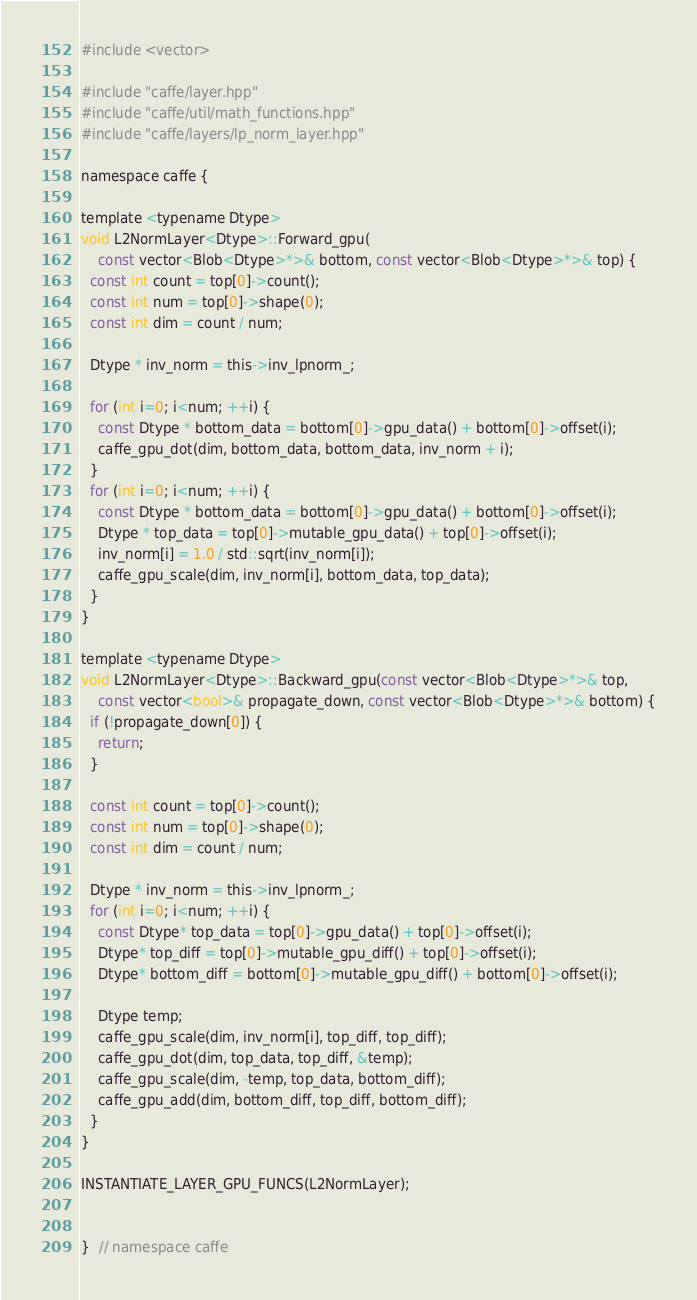<code> <loc_0><loc_0><loc_500><loc_500><_Cuda_>#include <vector>

#include "caffe/layer.hpp"
#include "caffe/util/math_functions.hpp"
#include "caffe/layers/lp_norm_layer.hpp"

namespace caffe {

template <typename Dtype>
void L2NormLayer<Dtype>::Forward_gpu(
    const vector<Blob<Dtype>*>& bottom, const vector<Blob<Dtype>*>& top) {
  const int count = top[0]->count();
  const int num = top[0]->shape(0);
  const int dim = count / num;

  Dtype * inv_norm = this->inv_lpnorm_;

  for (int i=0; i<num; ++i) {
    const Dtype * bottom_data = bottom[0]->gpu_data() + bottom[0]->offset(i);
    caffe_gpu_dot(dim, bottom_data, bottom_data, inv_norm + i);
  }
  for (int i=0; i<num; ++i) {
    const Dtype * bottom_data = bottom[0]->gpu_data() + bottom[0]->offset(i);
    Dtype * top_data = top[0]->mutable_gpu_data() + top[0]->offset(i);
    inv_norm[i] = 1.0 / std::sqrt(inv_norm[i]);
    caffe_gpu_scale(dim, inv_norm[i], bottom_data, top_data);
  }
}

template <typename Dtype>
void L2NormLayer<Dtype>::Backward_gpu(const vector<Blob<Dtype>*>& top,
    const vector<bool>& propagate_down, const vector<Blob<Dtype>*>& bottom) {
  if (!propagate_down[0]) {
    return;
  }

  const int count = top[0]->count();
  const int num = top[0]->shape(0);
  const int dim = count / num;

  Dtype * inv_norm = this->inv_lpnorm_;
  for (int i=0; i<num; ++i) {
    const Dtype* top_data = top[0]->gpu_data() + top[0]->offset(i);
    Dtype* top_diff = top[0]->mutable_gpu_diff() + top[0]->offset(i);
    Dtype* bottom_diff = bottom[0]->mutable_gpu_diff() + bottom[0]->offset(i);

    Dtype temp;
    caffe_gpu_scale(dim, inv_norm[i], top_diff, top_diff);
    caffe_gpu_dot(dim, top_data, top_diff, &temp);
    caffe_gpu_scale(dim, -temp, top_data, bottom_diff);
    caffe_gpu_add(dim, bottom_diff, top_diff, bottom_diff);
  }
}

INSTANTIATE_LAYER_GPU_FUNCS(L2NormLayer);


}  // namespace caffe
</code> 